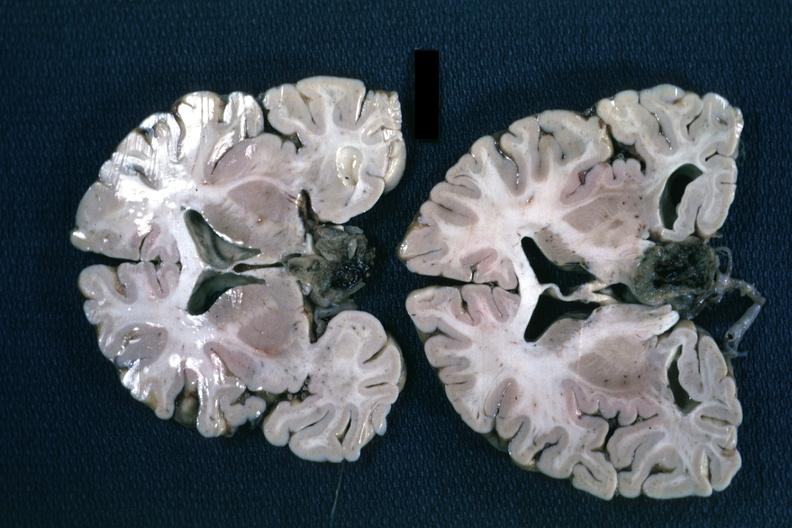does siamese twins show fixed tissue coronal sections hemispheres with large inferior lesion?
Answer the question using a single word or phrase. No 